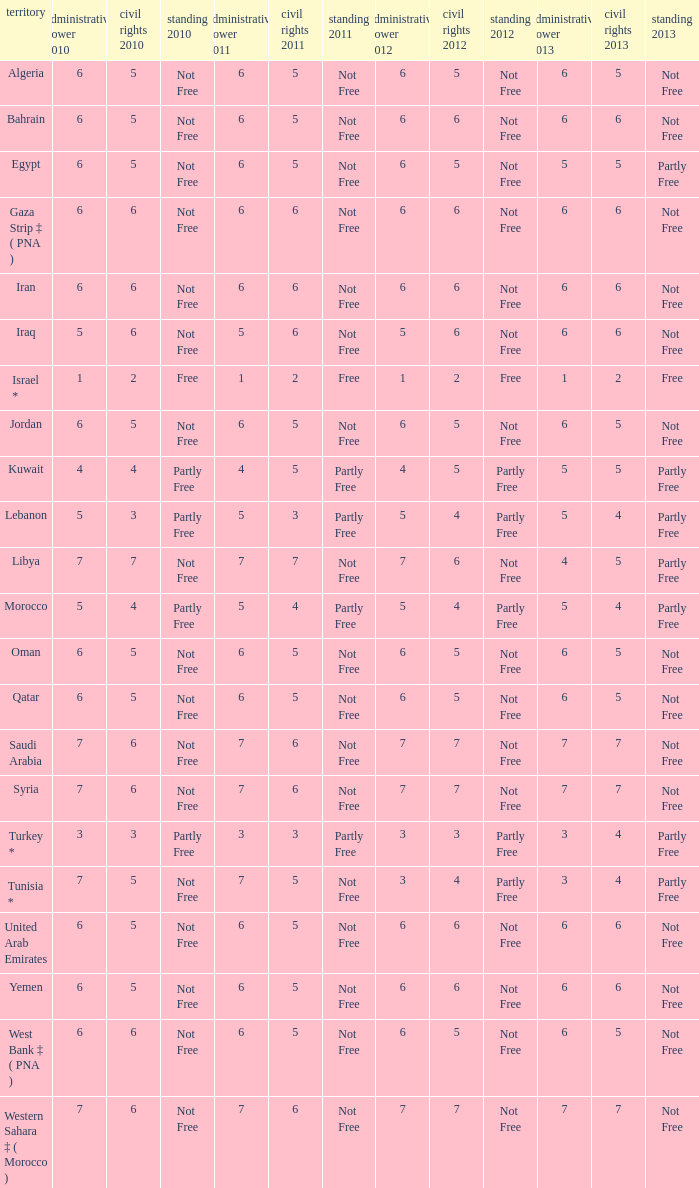What is the total number of civil liberties 2011 values having 2010 political rights values under 3 and 2011 political rights values under 1? 0.0. 